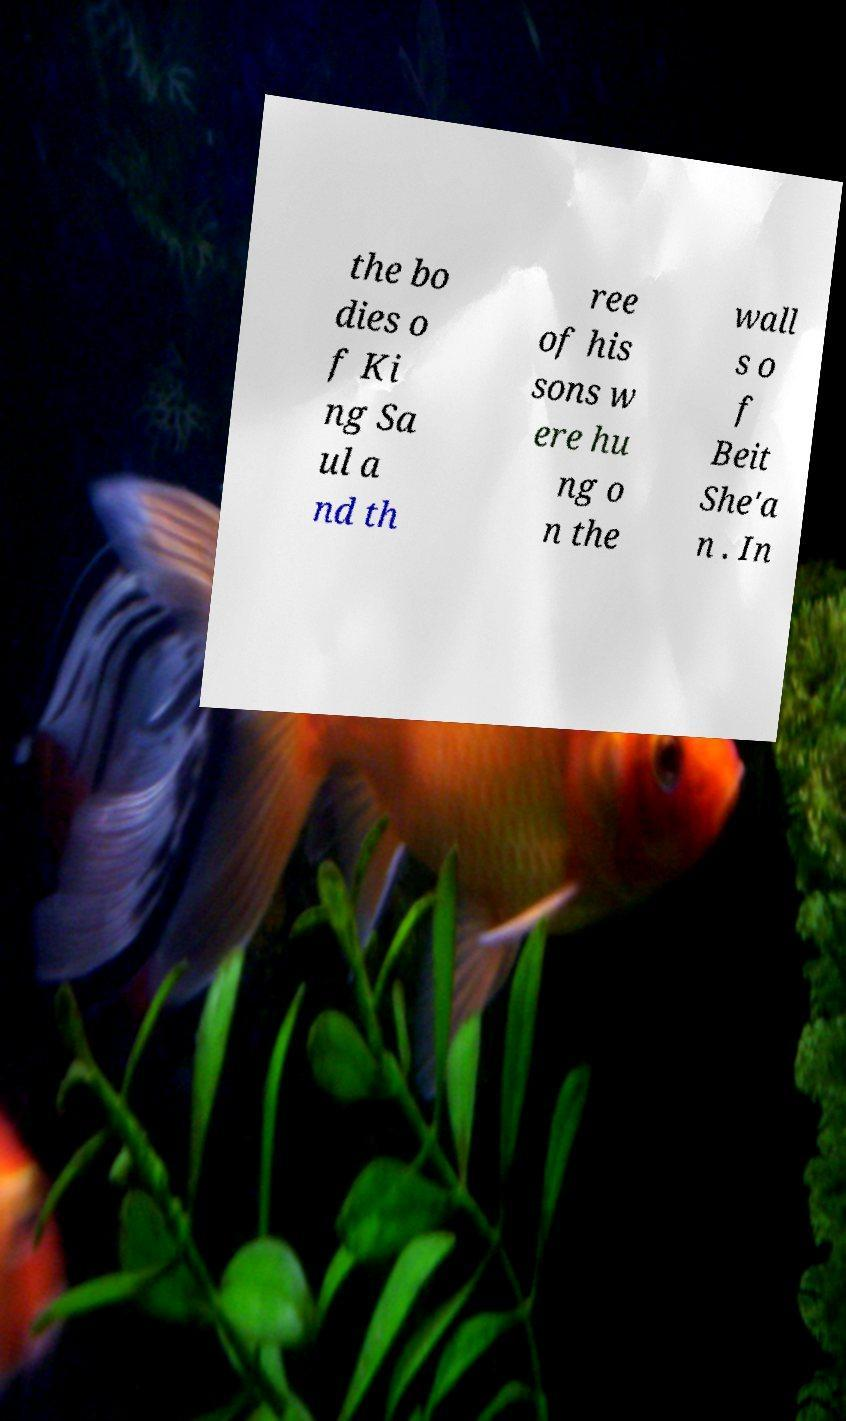Please read and relay the text visible in this image. What does it say? the bo dies o f Ki ng Sa ul a nd th ree of his sons w ere hu ng o n the wall s o f Beit She'a n . In 